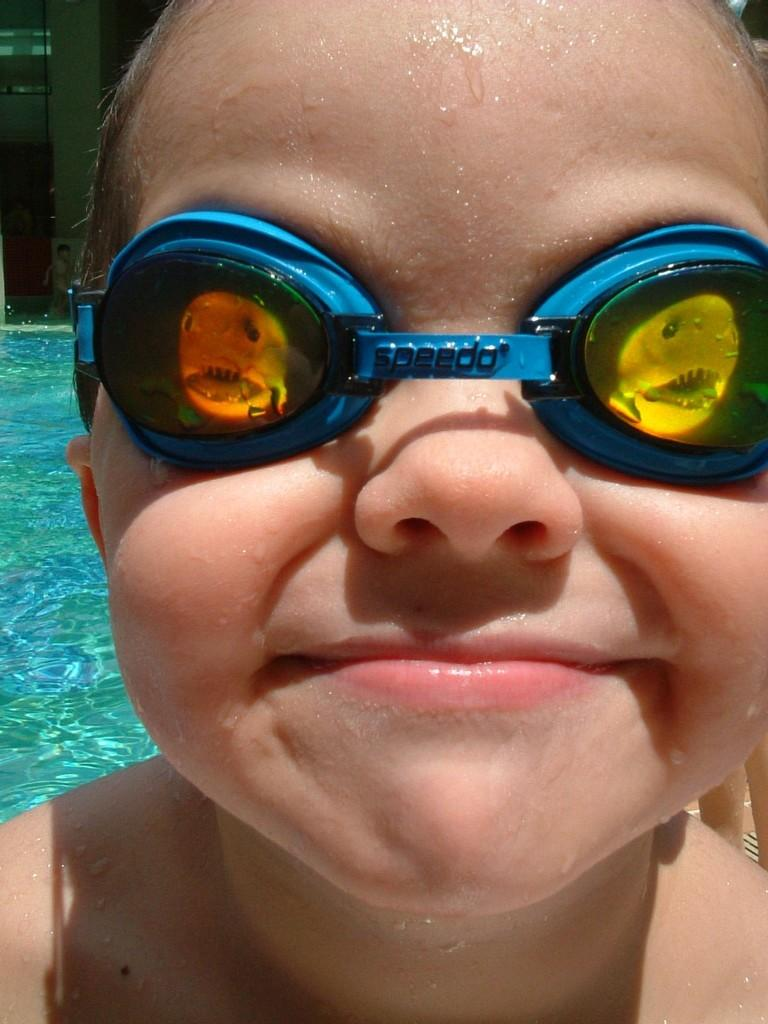What is the main subject of the picture? The main subject of the picture is a kid. Can you describe the kid's appearance? The kid is wearing spectacles. What can be seen in the background of the picture? There is water and other people visible in the background of the picture. What type of discussion is taking place between the lizards in the image? There are no lizards present in the image, so no discussion can be observed. Can you describe the crow's interaction with the kid in the image? There is no crow present in the image, so no interaction can be observed. 